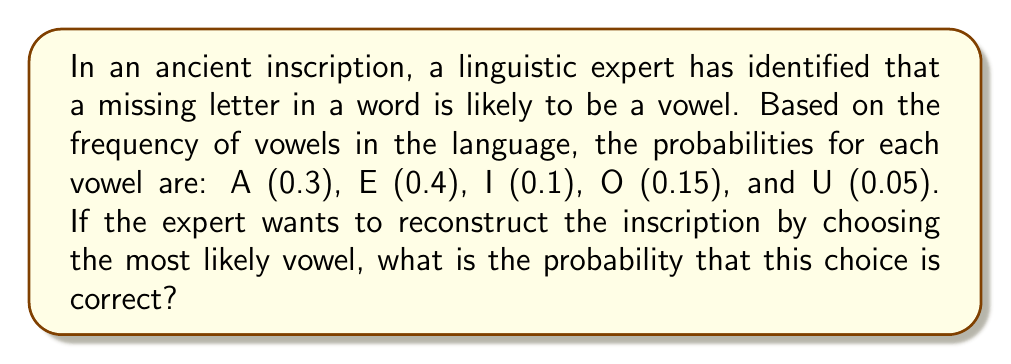Teach me how to tackle this problem. To solve this problem, we need to follow these steps:

1. Identify the given probabilities for each vowel:
   $P(A) = 0.3$
   $P(E) = 0.4$
   $P(I) = 0.1$
   $P(O) = 0.15$
   $P(U) = 0.05$

2. Determine the most likely vowel:
   The vowel with the highest probability is E, with $P(E) = 0.4$.

3. Calculate the probability that choosing E is correct:
   Since the expert will choose E, and E has a probability of 0.4, the probability that this choice is correct is simply 0.4 or 40%.

This problem demonstrates the application of probability models in reconstructing missing letters in ancient inscriptions, which is relevant to the linguistic expert's work in cross-verifying references about historical languages.
Answer: 0.4 